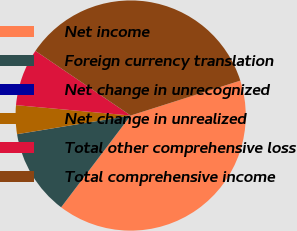Convert chart. <chart><loc_0><loc_0><loc_500><loc_500><pie_chart><fcel>Net income<fcel>Foreign currency translation<fcel>Net change in unrecognized<fcel>Net change in unrealized<fcel>Total other comprehensive loss<fcel>Total comprehensive income<nl><fcel>40.22%<fcel>12.08%<fcel>0.01%<fcel>4.03%<fcel>8.05%<fcel>35.6%<nl></chart> 